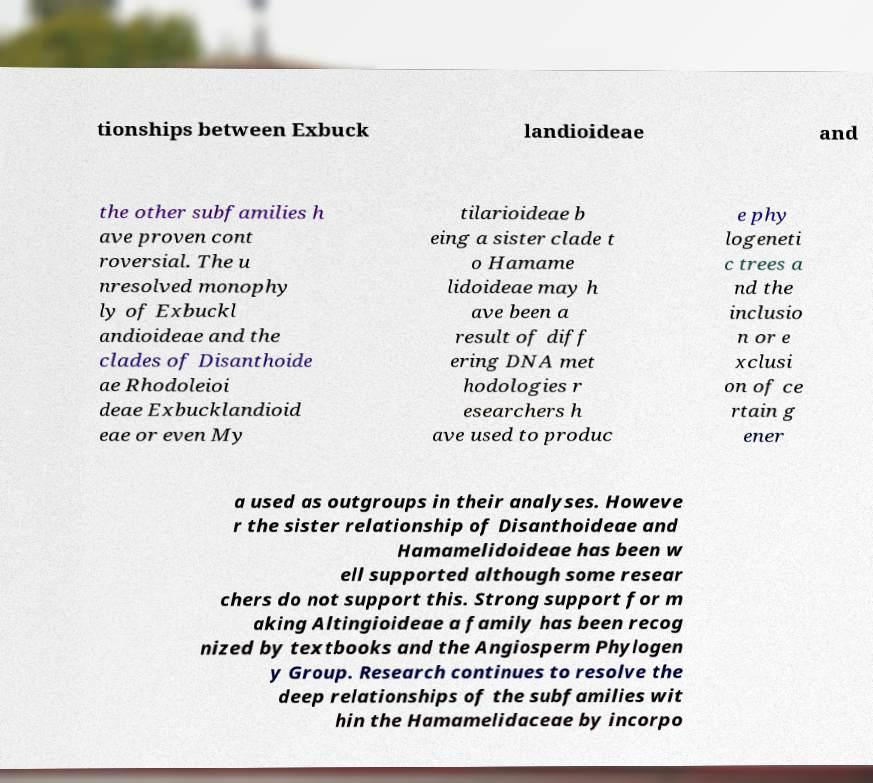For documentation purposes, I need the text within this image transcribed. Could you provide that? tionships between Exbuck landioideae and the other subfamilies h ave proven cont roversial. The u nresolved monophy ly of Exbuckl andioideae and the clades of Disanthoide ae Rhodoleioi deae Exbucklandioid eae or even My tilarioideae b eing a sister clade t o Hamame lidoideae may h ave been a result of diff ering DNA met hodologies r esearchers h ave used to produc e phy logeneti c trees a nd the inclusio n or e xclusi on of ce rtain g ener a used as outgroups in their analyses. Howeve r the sister relationship of Disanthoideae and Hamamelidoideae has been w ell supported although some resear chers do not support this. Strong support for m aking Altingioideae a family has been recog nized by textbooks and the Angiosperm Phylogen y Group. Research continues to resolve the deep relationships of the subfamilies wit hin the Hamamelidaceae by incorpo 